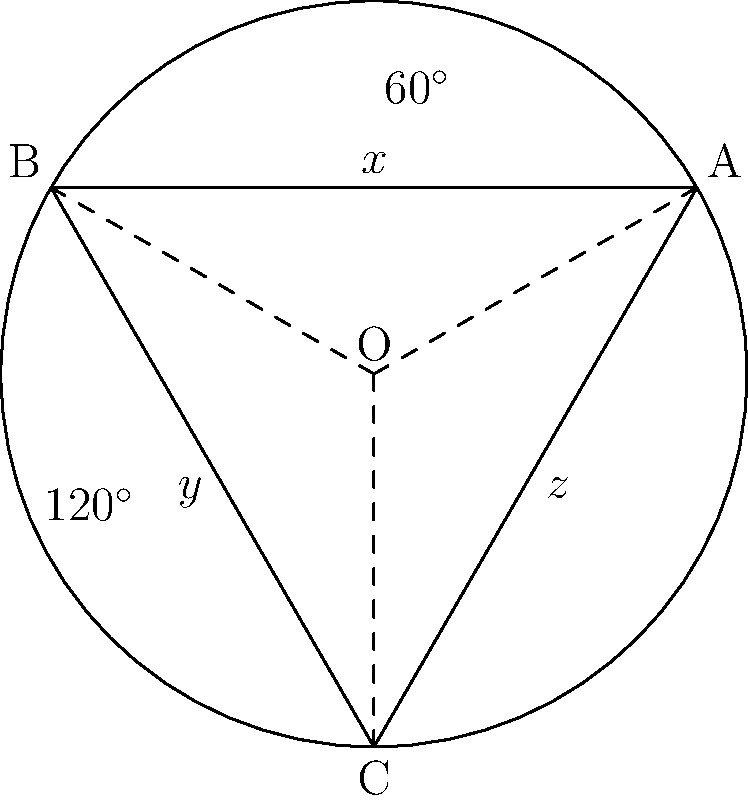In a circular sanctuary, three intersecting pews form a triangle ABC inscribed in the circle. The central angles subtended by the pews are $60^\circ$, $120^\circ$, and $180^\circ$. If the angles formed by the intersecting pews are labeled $x$, $y$, and $z$ as shown in the diagram, what is the value of $x + y + z$? Let's approach this step-by-step:

1) First, recall the inscribed angle theorem: an inscribed angle is half the central angle that subtends the same arc.

2) For angle $x$:
   Central angle = $60^\circ$
   Therefore, $x = 60^\circ / 2 = 30^\circ$

3) For angle $y$:
   Central angle = $120^\circ$
   Therefore, $y = 120^\circ / 2 = 60^\circ$

4) For angle $z$:
   Central angle = $180^\circ$
   Therefore, $z = 180^\circ / 2 = 90^\circ$

5) Now, we can sum up the angles:
   $x + y + z = 30^\circ + 60^\circ + 90^\circ = 180^\circ$

6) This result is consistent with the fact that the sum of angles in a triangle is always $180^\circ$.
Answer: $180^\circ$ 